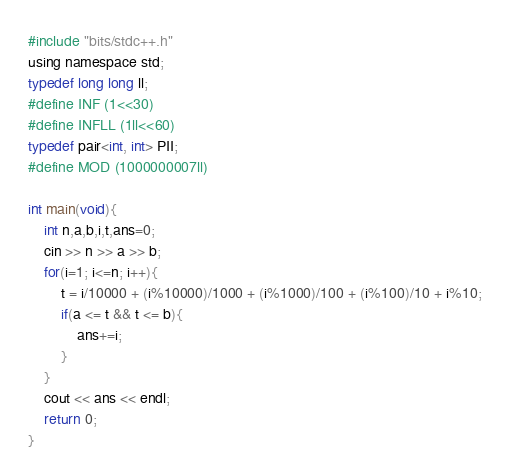<code> <loc_0><loc_0><loc_500><loc_500><_C_>#include "bits/stdc++.h"
using namespace std;
typedef long long ll;
#define INF (1<<30)
#define INFLL (1ll<<60)
typedef pair<int, int> PII;
#define MOD (1000000007ll)

int main(void){
	int n,a,b,i,t,ans=0;
	cin >> n >> a >> b;
	for(i=1; i<=n; i++){
		t = i/10000 + (i%10000)/1000 + (i%1000)/100 + (i%100)/10 + i%10;
		if(a <= t && t <= b){
			ans+=i;
		}
	}
	cout << ans << endl;
	return 0;
}</code> 